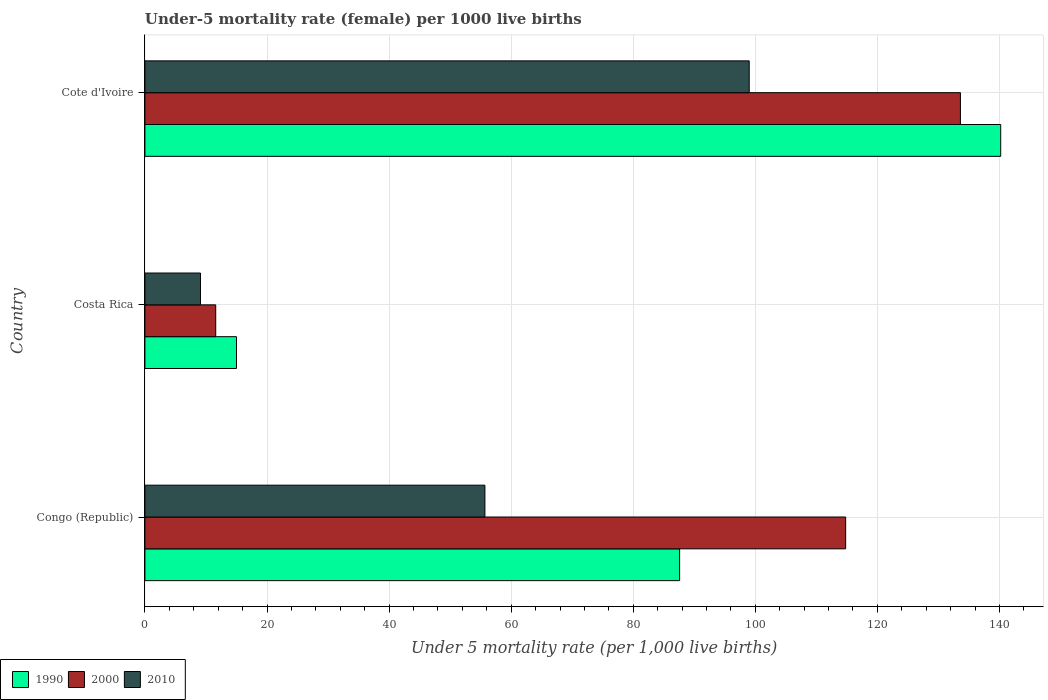Are the number of bars per tick equal to the number of legend labels?
Your answer should be very brief. Yes. How many bars are there on the 1st tick from the top?
Your response must be concise. 3. How many bars are there on the 2nd tick from the bottom?
Ensure brevity in your answer.  3. What is the label of the 3rd group of bars from the top?
Your answer should be compact. Congo (Republic). What is the under-five mortality rate in 1990 in Congo (Republic)?
Ensure brevity in your answer.  87.6. Across all countries, what is the maximum under-five mortality rate in 2010?
Ensure brevity in your answer.  99. Across all countries, what is the minimum under-five mortality rate in 2000?
Provide a short and direct response. 11.6. In which country was the under-five mortality rate in 1990 maximum?
Your response must be concise. Cote d'Ivoire. In which country was the under-five mortality rate in 1990 minimum?
Provide a succinct answer. Costa Rica. What is the total under-five mortality rate in 2010 in the graph?
Your answer should be very brief. 163.8. What is the difference between the under-five mortality rate in 2000 in Congo (Republic) and that in Cote d'Ivoire?
Provide a short and direct response. -18.8. What is the difference between the under-five mortality rate in 2000 in Congo (Republic) and the under-five mortality rate in 1990 in Cote d'Ivoire?
Provide a short and direct response. -25.4. What is the average under-five mortality rate in 1990 per country?
Make the answer very short. 80.93. What is the difference between the under-five mortality rate in 2000 and under-five mortality rate in 2010 in Cote d'Ivoire?
Ensure brevity in your answer.  34.6. In how many countries, is the under-five mortality rate in 2010 greater than 72 ?
Your answer should be compact. 1. What is the ratio of the under-five mortality rate in 2000 in Costa Rica to that in Cote d'Ivoire?
Offer a terse response. 0.09. Is the under-five mortality rate in 2000 in Congo (Republic) less than that in Cote d'Ivoire?
Make the answer very short. Yes. What is the difference between the highest and the second highest under-five mortality rate in 1990?
Your answer should be very brief. 52.6. What is the difference between the highest and the lowest under-five mortality rate in 2000?
Your response must be concise. 122. What does the 3rd bar from the bottom in Costa Rica represents?
Your answer should be compact. 2010. How many bars are there?
Keep it short and to the point. 9. How many countries are there in the graph?
Make the answer very short. 3. What is the difference between two consecutive major ticks on the X-axis?
Provide a succinct answer. 20. Does the graph contain grids?
Your answer should be compact. Yes. How many legend labels are there?
Give a very brief answer. 3. What is the title of the graph?
Your answer should be compact. Under-5 mortality rate (female) per 1000 live births. Does "2011" appear as one of the legend labels in the graph?
Your answer should be very brief. No. What is the label or title of the X-axis?
Make the answer very short. Under 5 mortality rate (per 1,0 live births). What is the Under 5 mortality rate (per 1,000 live births) in 1990 in Congo (Republic)?
Make the answer very short. 87.6. What is the Under 5 mortality rate (per 1,000 live births) of 2000 in Congo (Republic)?
Offer a terse response. 114.8. What is the Under 5 mortality rate (per 1,000 live births) in 2010 in Congo (Republic)?
Keep it short and to the point. 55.7. What is the Under 5 mortality rate (per 1,000 live births) of 2010 in Costa Rica?
Your answer should be compact. 9.1. What is the Under 5 mortality rate (per 1,000 live births) in 1990 in Cote d'Ivoire?
Offer a very short reply. 140.2. What is the Under 5 mortality rate (per 1,000 live births) of 2000 in Cote d'Ivoire?
Your response must be concise. 133.6. What is the Under 5 mortality rate (per 1,000 live births) in 2010 in Cote d'Ivoire?
Provide a succinct answer. 99. Across all countries, what is the maximum Under 5 mortality rate (per 1,000 live births) of 1990?
Offer a very short reply. 140.2. Across all countries, what is the maximum Under 5 mortality rate (per 1,000 live births) of 2000?
Provide a succinct answer. 133.6. Across all countries, what is the maximum Under 5 mortality rate (per 1,000 live births) in 2010?
Keep it short and to the point. 99. What is the total Under 5 mortality rate (per 1,000 live births) of 1990 in the graph?
Ensure brevity in your answer.  242.8. What is the total Under 5 mortality rate (per 1,000 live births) of 2000 in the graph?
Your response must be concise. 260. What is the total Under 5 mortality rate (per 1,000 live births) in 2010 in the graph?
Offer a terse response. 163.8. What is the difference between the Under 5 mortality rate (per 1,000 live births) in 1990 in Congo (Republic) and that in Costa Rica?
Your answer should be compact. 72.6. What is the difference between the Under 5 mortality rate (per 1,000 live births) in 2000 in Congo (Republic) and that in Costa Rica?
Offer a terse response. 103.2. What is the difference between the Under 5 mortality rate (per 1,000 live births) of 2010 in Congo (Republic) and that in Costa Rica?
Offer a terse response. 46.6. What is the difference between the Under 5 mortality rate (per 1,000 live births) in 1990 in Congo (Republic) and that in Cote d'Ivoire?
Offer a very short reply. -52.6. What is the difference between the Under 5 mortality rate (per 1,000 live births) of 2000 in Congo (Republic) and that in Cote d'Ivoire?
Your answer should be compact. -18.8. What is the difference between the Under 5 mortality rate (per 1,000 live births) in 2010 in Congo (Republic) and that in Cote d'Ivoire?
Provide a succinct answer. -43.3. What is the difference between the Under 5 mortality rate (per 1,000 live births) of 1990 in Costa Rica and that in Cote d'Ivoire?
Your answer should be compact. -125.2. What is the difference between the Under 5 mortality rate (per 1,000 live births) of 2000 in Costa Rica and that in Cote d'Ivoire?
Give a very brief answer. -122. What is the difference between the Under 5 mortality rate (per 1,000 live births) of 2010 in Costa Rica and that in Cote d'Ivoire?
Provide a short and direct response. -89.9. What is the difference between the Under 5 mortality rate (per 1,000 live births) in 1990 in Congo (Republic) and the Under 5 mortality rate (per 1,000 live births) in 2000 in Costa Rica?
Provide a short and direct response. 76. What is the difference between the Under 5 mortality rate (per 1,000 live births) of 1990 in Congo (Republic) and the Under 5 mortality rate (per 1,000 live births) of 2010 in Costa Rica?
Provide a short and direct response. 78.5. What is the difference between the Under 5 mortality rate (per 1,000 live births) in 2000 in Congo (Republic) and the Under 5 mortality rate (per 1,000 live births) in 2010 in Costa Rica?
Keep it short and to the point. 105.7. What is the difference between the Under 5 mortality rate (per 1,000 live births) of 1990 in Congo (Republic) and the Under 5 mortality rate (per 1,000 live births) of 2000 in Cote d'Ivoire?
Provide a short and direct response. -46. What is the difference between the Under 5 mortality rate (per 1,000 live births) in 1990 in Costa Rica and the Under 5 mortality rate (per 1,000 live births) in 2000 in Cote d'Ivoire?
Make the answer very short. -118.6. What is the difference between the Under 5 mortality rate (per 1,000 live births) in 1990 in Costa Rica and the Under 5 mortality rate (per 1,000 live births) in 2010 in Cote d'Ivoire?
Offer a terse response. -84. What is the difference between the Under 5 mortality rate (per 1,000 live births) in 2000 in Costa Rica and the Under 5 mortality rate (per 1,000 live births) in 2010 in Cote d'Ivoire?
Provide a succinct answer. -87.4. What is the average Under 5 mortality rate (per 1,000 live births) of 1990 per country?
Keep it short and to the point. 80.93. What is the average Under 5 mortality rate (per 1,000 live births) in 2000 per country?
Your answer should be very brief. 86.67. What is the average Under 5 mortality rate (per 1,000 live births) in 2010 per country?
Offer a very short reply. 54.6. What is the difference between the Under 5 mortality rate (per 1,000 live births) of 1990 and Under 5 mortality rate (per 1,000 live births) of 2000 in Congo (Republic)?
Offer a very short reply. -27.2. What is the difference between the Under 5 mortality rate (per 1,000 live births) of 1990 and Under 5 mortality rate (per 1,000 live births) of 2010 in Congo (Republic)?
Your response must be concise. 31.9. What is the difference between the Under 5 mortality rate (per 1,000 live births) in 2000 and Under 5 mortality rate (per 1,000 live births) in 2010 in Congo (Republic)?
Your answer should be very brief. 59.1. What is the difference between the Under 5 mortality rate (per 1,000 live births) in 1990 and Under 5 mortality rate (per 1,000 live births) in 2010 in Costa Rica?
Give a very brief answer. 5.9. What is the difference between the Under 5 mortality rate (per 1,000 live births) of 1990 and Under 5 mortality rate (per 1,000 live births) of 2000 in Cote d'Ivoire?
Give a very brief answer. 6.6. What is the difference between the Under 5 mortality rate (per 1,000 live births) in 1990 and Under 5 mortality rate (per 1,000 live births) in 2010 in Cote d'Ivoire?
Give a very brief answer. 41.2. What is the difference between the Under 5 mortality rate (per 1,000 live births) of 2000 and Under 5 mortality rate (per 1,000 live births) of 2010 in Cote d'Ivoire?
Your response must be concise. 34.6. What is the ratio of the Under 5 mortality rate (per 1,000 live births) of 1990 in Congo (Republic) to that in Costa Rica?
Your answer should be compact. 5.84. What is the ratio of the Under 5 mortality rate (per 1,000 live births) in 2000 in Congo (Republic) to that in Costa Rica?
Provide a short and direct response. 9.9. What is the ratio of the Under 5 mortality rate (per 1,000 live births) in 2010 in Congo (Republic) to that in Costa Rica?
Offer a terse response. 6.12. What is the ratio of the Under 5 mortality rate (per 1,000 live births) of 1990 in Congo (Republic) to that in Cote d'Ivoire?
Ensure brevity in your answer.  0.62. What is the ratio of the Under 5 mortality rate (per 1,000 live births) in 2000 in Congo (Republic) to that in Cote d'Ivoire?
Offer a very short reply. 0.86. What is the ratio of the Under 5 mortality rate (per 1,000 live births) in 2010 in Congo (Republic) to that in Cote d'Ivoire?
Make the answer very short. 0.56. What is the ratio of the Under 5 mortality rate (per 1,000 live births) in 1990 in Costa Rica to that in Cote d'Ivoire?
Offer a very short reply. 0.11. What is the ratio of the Under 5 mortality rate (per 1,000 live births) in 2000 in Costa Rica to that in Cote d'Ivoire?
Your response must be concise. 0.09. What is the ratio of the Under 5 mortality rate (per 1,000 live births) in 2010 in Costa Rica to that in Cote d'Ivoire?
Ensure brevity in your answer.  0.09. What is the difference between the highest and the second highest Under 5 mortality rate (per 1,000 live births) of 1990?
Your answer should be very brief. 52.6. What is the difference between the highest and the second highest Under 5 mortality rate (per 1,000 live births) of 2000?
Your answer should be compact. 18.8. What is the difference between the highest and the second highest Under 5 mortality rate (per 1,000 live births) in 2010?
Provide a succinct answer. 43.3. What is the difference between the highest and the lowest Under 5 mortality rate (per 1,000 live births) of 1990?
Offer a terse response. 125.2. What is the difference between the highest and the lowest Under 5 mortality rate (per 1,000 live births) of 2000?
Ensure brevity in your answer.  122. What is the difference between the highest and the lowest Under 5 mortality rate (per 1,000 live births) of 2010?
Provide a short and direct response. 89.9. 